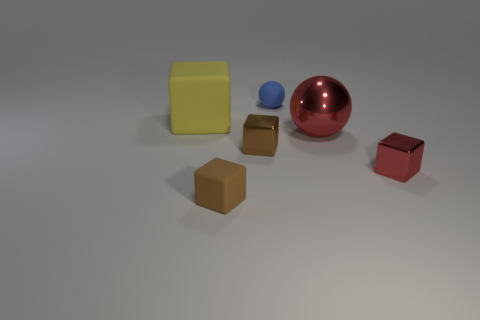Add 2 large red shiny objects. How many objects exist? 8 Subtract all spheres. How many objects are left? 4 Add 1 metallic cubes. How many metallic cubes exist? 3 Subtract 0 yellow cylinders. How many objects are left? 6 Subtract all small matte blocks. Subtract all brown shiny objects. How many objects are left? 4 Add 5 small rubber objects. How many small rubber objects are left? 7 